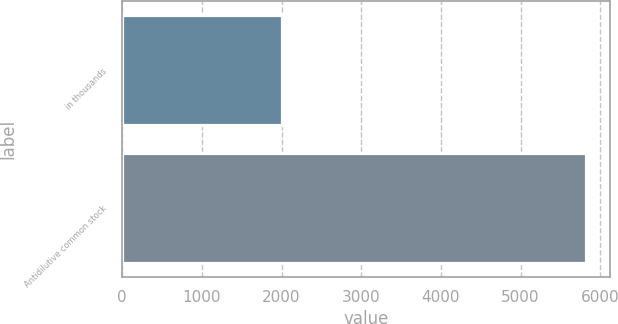Convert chart. <chart><loc_0><loc_0><loc_500><loc_500><bar_chart><fcel>in thousands<fcel>Antidilutive common stock<nl><fcel>2010<fcel>5827<nl></chart> 